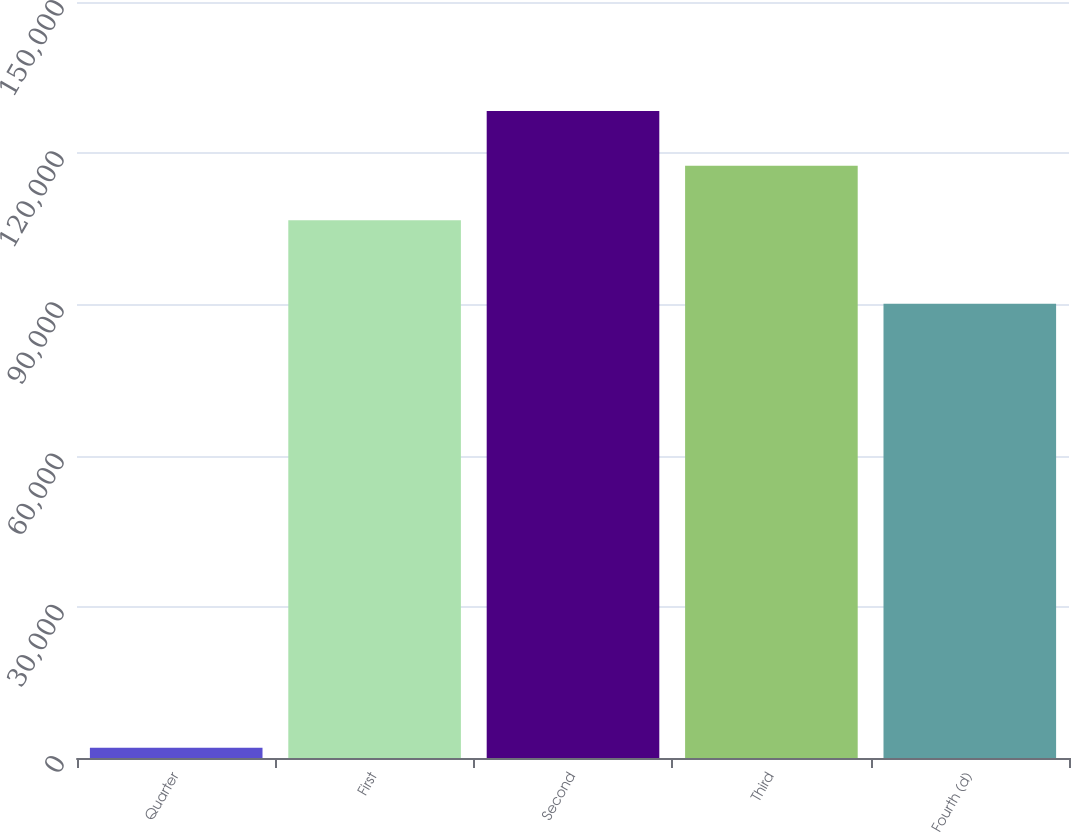<chart> <loc_0><loc_0><loc_500><loc_500><bar_chart><fcel>Quarter<fcel>First<fcel>Second<fcel>Third<fcel>Fourth (d)<nl><fcel>2014<fcel>106707<fcel>128361<fcel>117534<fcel>90136<nl></chart> 